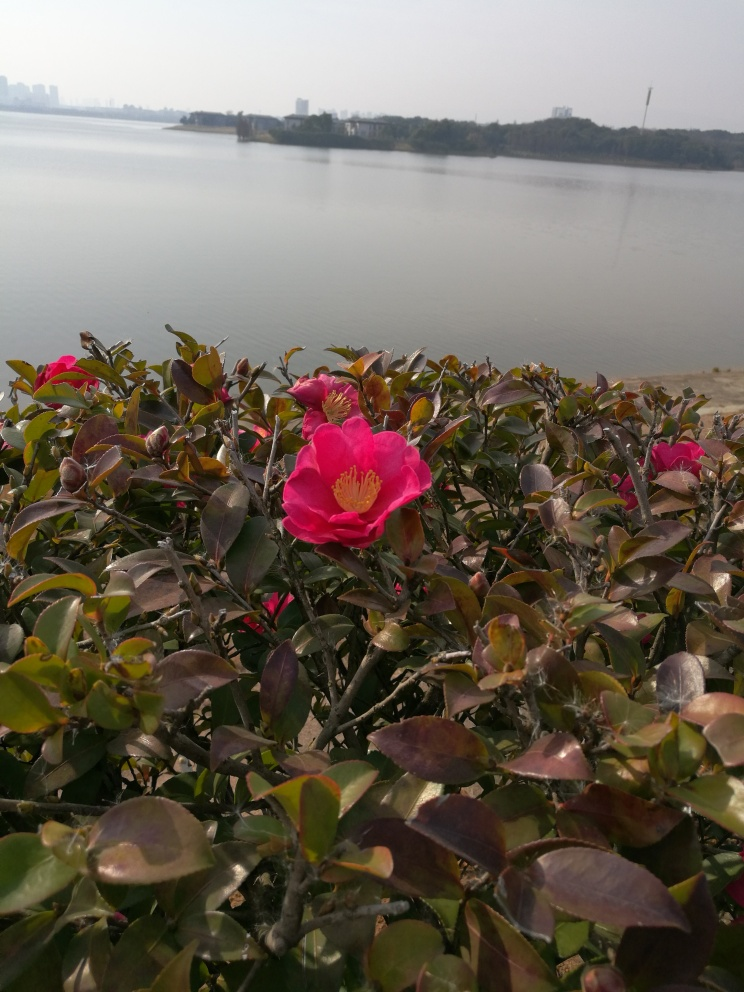Do the main subjects, the flowers, have rich and clear texture details? The flowers in the image possess a distinct and vivid texture. The petals show a delicate gradation of pink, with deeper shades at the base and lighter tones near the edges, with the central stamen featuring prominent yellow anthers that stand out against the petals. Moreover, the surrounding foliage provides a rich backdrop with shiny, leathery leaves that exhibit a variety of colors, from deep greens to purplish tones, adding depth and complexity to the image. 